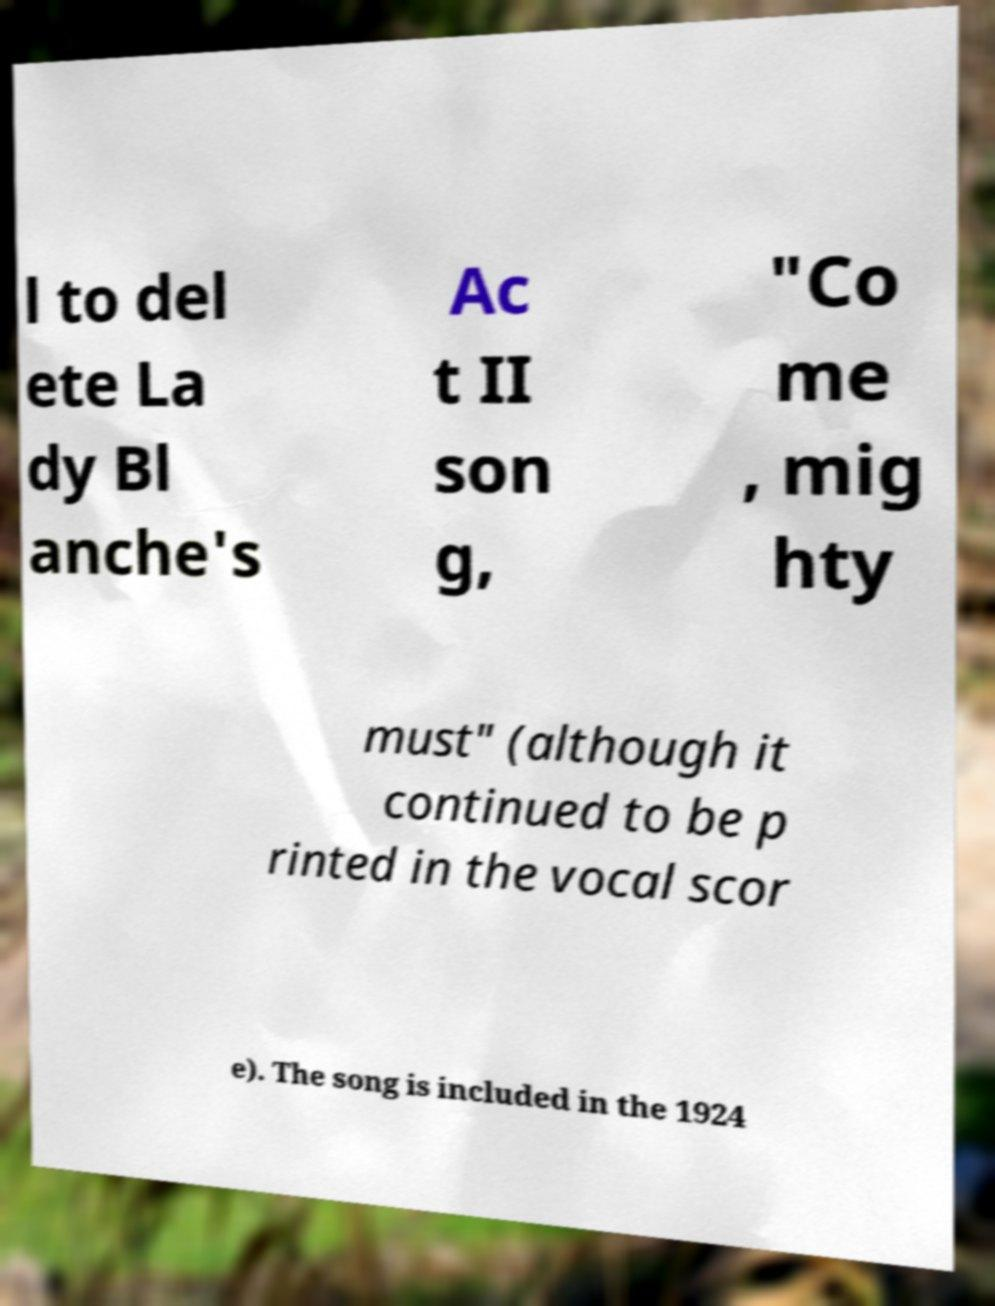Please identify and transcribe the text found in this image. l to del ete La dy Bl anche's Ac t II son g, "Co me , mig hty must" (although it continued to be p rinted in the vocal scor e). The song is included in the 1924 